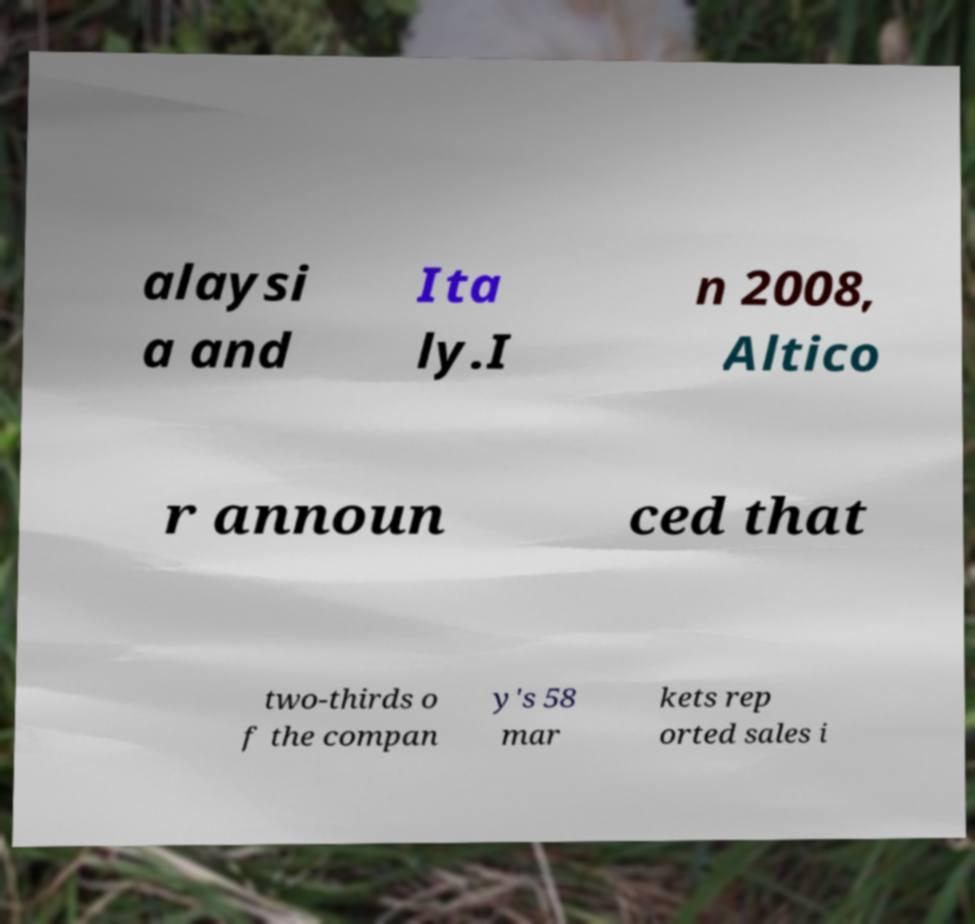Please read and relay the text visible in this image. What does it say? alaysi a and Ita ly.I n 2008, Altico r announ ced that two-thirds o f the compan y's 58 mar kets rep orted sales i 